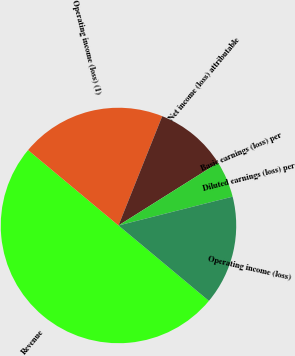Convert chart. <chart><loc_0><loc_0><loc_500><loc_500><pie_chart><fcel>Revenue<fcel>Operating income (loss) (1)<fcel>Net income (loss) attributable<fcel>Basic earnings (loss) per<fcel>Diluted earnings (loss) per<fcel>Operating income (loss)<nl><fcel>50.0%<fcel>20.0%<fcel>10.0%<fcel>5.0%<fcel>0.0%<fcel>15.0%<nl></chart> 